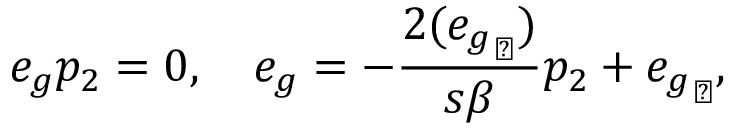<formula> <loc_0><loc_0><loc_500><loc_500>e _ { g } p _ { 2 } = 0 , \quad e _ { g } = - \frac { 2 ( { e _ { g } } _ { \perp } ) } { s \beta } p _ { 2 } + { e _ { g } } _ { \perp } ,</formula> 